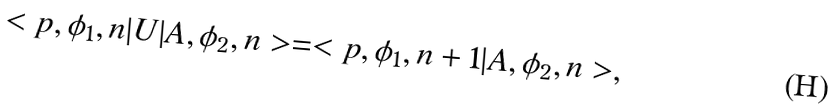<formula> <loc_0><loc_0><loc_500><loc_500>< p , \phi _ { 1 } , n | U | A , \phi _ { 2 } , n > = < p , \phi _ { 1 } , n + 1 | A , \phi _ { 2 } , n > ,</formula> 